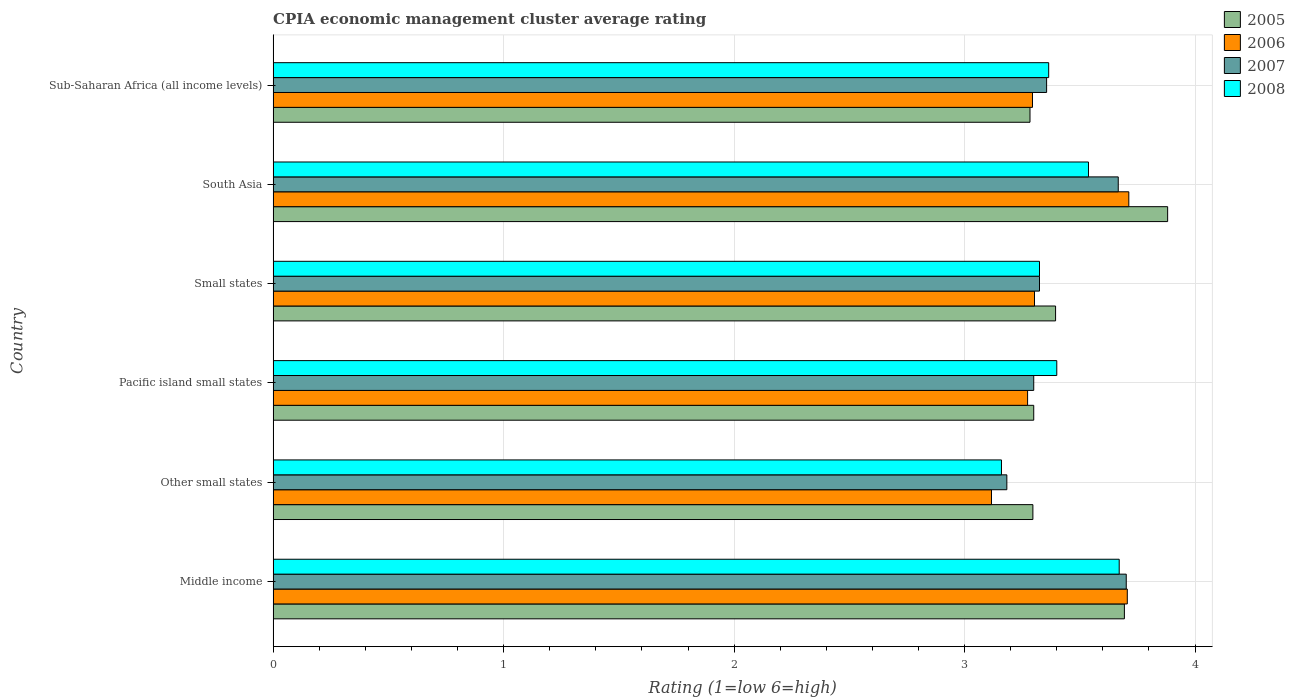How many different coloured bars are there?
Your answer should be compact. 4. Are the number of bars per tick equal to the number of legend labels?
Offer a terse response. Yes. What is the label of the 5th group of bars from the top?
Your answer should be very brief. Other small states. In how many cases, is the number of bars for a given country not equal to the number of legend labels?
Your answer should be compact. 0. What is the CPIA rating in 2005 in Sub-Saharan Africa (all income levels)?
Ensure brevity in your answer.  3.28. Across all countries, what is the maximum CPIA rating in 2005?
Provide a short and direct response. 3.88. Across all countries, what is the minimum CPIA rating in 2008?
Make the answer very short. 3.16. In which country was the CPIA rating in 2007 minimum?
Your response must be concise. Other small states. What is the total CPIA rating in 2008 in the graph?
Give a very brief answer. 20.46. What is the difference between the CPIA rating in 2005 in Small states and that in South Asia?
Offer a very short reply. -0.49. What is the difference between the CPIA rating in 2006 in South Asia and the CPIA rating in 2007 in Middle income?
Offer a terse response. 0.01. What is the average CPIA rating in 2007 per country?
Offer a terse response. 3.42. What is the difference between the CPIA rating in 2008 and CPIA rating in 2006 in Sub-Saharan Africa (all income levels)?
Provide a short and direct response. 0.07. In how many countries, is the CPIA rating in 2008 greater than 2 ?
Your answer should be very brief. 6. What is the ratio of the CPIA rating in 2008 in South Asia to that in Sub-Saharan Africa (all income levels)?
Give a very brief answer. 1.05. Is the CPIA rating in 2006 in Middle income less than that in South Asia?
Give a very brief answer. Yes. What is the difference between the highest and the second highest CPIA rating in 2006?
Provide a short and direct response. 0.01. What is the difference between the highest and the lowest CPIA rating in 2008?
Make the answer very short. 0.51. In how many countries, is the CPIA rating in 2005 greater than the average CPIA rating in 2005 taken over all countries?
Give a very brief answer. 2. Is the sum of the CPIA rating in 2006 in Other small states and Sub-Saharan Africa (all income levels) greater than the maximum CPIA rating in 2007 across all countries?
Your answer should be compact. Yes. Is it the case that in every country, the sum of the CPIA rating in 2007 and CPIA rating in 2005 is greater than the sum of CPIA rating in 2006 and CPIA rating in 2008?
Keep it short and to the point. No. What does the 4th bar from the top in Pacific island small states represents?
Keep it short and to the point. 2005. What does the 3rd bar from the bottom in Sub-Saharan Africa (all income levels) represents?
Keep it short and to the point. 2007. What is the difference between two consecutive major ticks on the X-axis?
Give a very brief answer. 1. Are the values on the major ticks of X-axis written in scientific E-notation?
Provide a succinct answer. No. What is the title of the graph?
Keep it short and to the point. CPIA economic management cluster average rating. Does "2002" appear as one of the legend labels in the graph?
Your answer should be very brief. No. What is the label or title of the X-axis?
Ensure brevity in your answer.  Rating (1=low 6=high). What is the Rating (1=low 6=high) in 2005 in Middle income?
Your response must be concise. 3.69. What is the Rating (1=low 6=high) in 2006 in Middle income?
Offer a very short reply. 3.71. What is the Rating (1=low 6=high) in 2007 in Middle income?
Offer a terse response. 3.7. What is the Rating (1=low 6=high) of 2008 in Middle income?
Provide a succinct answer. 3.67. What is the Rating (1=low 6=high) of 2005 in Other small states?
Keep it short and to the point. 3.3. What is the Rating (1=low 6=high) of 2006 in Other small states?
Your answer should be compact. 3.12. What is the Rating (1=low 6=high) in 2007 in Other small states?
Provide a short and direct response. 3.18. What is the Rating (1=low 6=high) in 2008 in Other small states?
Offer a very short reply. 3.16. What is the Rating (1=low 6=high) of 2005 in Pacific island small states?
Your response must be concise. 3.3. What is the Rating (1=low 6=high) of 2006 in Pacific island small states?
Your answer should be very brief. 3.27. What is the Rating (1=low 6=high) of 2005 in Small states?
Provide a short and direct response. 3.39. What is the Rating (1=low 6=high) of 2006 in Small states?
Your answer should be compact. 3.3. What is the Rating (1=low 6=high) of 2007 in Small states?
Your response must be concise. 3.33. What is the Rating (1=low 6=high) in 2008 in Small states?
Offer a very short reply. 3.33. What is the Rating (1=low 6=high) in 2005 in South Asia?
Offer a very short reply. 3.88. What is the Rating (1=low 6=high) of 2006 in South Asia?
Keep it short and to the point. 3.71. What is the Rating (1=low 6=high) in 2007 in South Asia?
Offer a very short reply. 3.67. What is the Rating (1=low 6=high) of 2008 in South Asia?
Make the answer very short. 3.54. What is the Rating (1=low 6=high) in 2005 in Sub-Saharan Africa (all income levels)?
Provide a succinct answer. 3.28. What is the Rating (1=low 6=high) in 2006 in Sub-Saharan Africa (all income levels)?
Provide a succinct answer. 3.29. What is the Rating (1=low 6=high) of 2007 in Sub-Saharan Africa (all income levels)?
Keep it short and to the point. 3.36. What is the Rating (1=low 6=high) of 2008 in Sub-Saharan Africa (all income levels)?
Offer a terse response. 3.36. Across all countries, what is the maximum Rating (1=low 6=high) in 2005?
Keep it short and to the point. 3.88. Across all countries, what is the maximum Rating (1=low 6=high) of 2006?
Offer a very short reply. 3.71. Across all countries, what is the maximum Rating (1=low 6=high) of 2007?
Ensure brevity in your answer.  3.7. Across all countries, what is the maximum Rating (1=low 6=high) of 2008?
Provide a short and direct response. 3.67. Across all countries, what is the minimum Rating (1=low 6=high) of 2005?
Offer a terse response. 3.28. Across all countries, what is the minimum Rating (1=low 6=high) in 2006?
Give a very brief answer. 3.12. Across all countries, what is the minimum Rating (1=low 6=high) of 2007?
Ensure brevity in your answer.  3.18. Across all countries, what is the minimum Rating (1=low 6=high) of 2008?
Your answer should be very brief. 3.16. What is the total Rating (1=low 6=high) in 2005 in the graph?
Your answer should be very brief. 20.85. What is the total Rating (1=low 6=high) in 2006 in the graph?
Ensure brevity in your answer.  20.41. What is the total Rating (1=low 6=high) in 2007 in the graph?
Ensure brevity in your answer.  20.53. What is the total Rating (1=low 6=high) in 2008 in the graph?
Ensure brevity in your answer.  20.46. What is the difference between the Rating (1=low 6=high) in 2005 in Middle income and that in Other small states?
Keep it short and to the point. 0.4. What is the difference between the Rating (1=low 6=high) of 2006 in Middle income and that in Other small states?
Offer a very short reply. 0.59. What is the difference between the Rating (1=low 6=high) in 2007 in Middle income and that in Other small states?
Ensure brevity in your answer.  0.52. What is the difference between the Rating (1=low 6=high) in 2008 in Middle income and that in Other small states?
Make the answer very short. 0.51. What is the difference between the Rating (1=low 6=high) in 2005 in Middle income and that in Pacific island small states?
Your answer should be very brief. 0.39. What is the difference between the Rating (1=low 6=high) of 2006 in Middle income and that in Pacific island small states?
Keep it short and to the point. 0.43. What is the difference between the Rating (1=low 6=high) in 2007 in Middle income and that in Pacific island small states?
Provide a succinct answer. 0.4. What is the difference between the Rating (1=low 6=high) in 2008 in Middle income and that in Pacific island small states?
Your answer should be very brief. 0.27. What is the difference between the Rating (1=low 6=high) of 2005 in Middle income and that in Small states?
Offer a terse response. 0.3. What is the difference between the Rating (1=low 6=high) of 2006 in Middle income and that in Small states?
Your answer should be compact. 0.4. What is the difference between the Rating (1=low 6=high) of 2007 in Middle income and that in Small states?
Keep it short and to the point. 0.38. What is the difference between the Rating (1=low 6=high) in 2008 in Middle income and that in Small states?
Provide a succinct answer. 0.35. What is the difference between the Rating (1=low 6=high) of 2005 in Middle income and that in South Asia?
Provide a short and direct response. -0.19. What is the difference between the Rating (1=low 6=high) in 2006 in Middle income and that in South Asia?
Offer a very short reply. -0.01. What is the difference between the Rating (1=low 6=high) in 2007 in Middle income and that in South Asia?
Your answer should be very brief. 0.03. What is the difference between the Rating (1=low 6=high) of 2008 in Middle income and that in South Asia?
Provide a short and direct response. 0.13. What is the difference between the Rating (1=low 6=high) of 2005 in Middle income and that in Sub-Saharan Africa (all income levels)?
Your response must be concise. 0.41. What is the difference between the Rating (1=low 6=high) in 2006 in Middle income and that in Sub-Saharan Africa (all income levels)?
Provide a succinct answer. 0.41. What is the difference between the Rating (1=low 6=high) in 2007 in Middle income and that in Sub-Saharan Africa (all income levels)?
Offer a very short reply. 0.35. What is the difference between the Rating (1=low 6=high) in 2008 in Middle income and that in Sub-Saharan Africa (all income levels)?
Offer a terse response. 0.31. What is the difference between the Rating (1=low 6=high) in 2005 in Other small states and that in Pacific island small states?
Your response must be concise. -0. What is the difference between the Rating (1=low 6=high) of 2006 in Other small states and that in Pacific island small states?
Your answer should be compact. -0.16. What is the difference between the Rating (1=low 6=high) of 2007 in Other small states and that in Pacific island small states?
Your answer should be very brief. -0.12. What is the difference between the Rating (1=low 6=high) in 2008 in Other small states and that in Pacific island small states?
Ensure brevity in your answer.  -0.24. What is the difference between the Rating (1=low 6=high) of 2005 in Other small states and that in Small states?
Your answer should be very brief. -0.1. What is the difference between the Rating (1=low 6=high) of 2006 in Other small states and that in Small states?
Your response must be concise. -0.19. What is the difference between the Rating (1=low 6=high) of 2007 in Other small states and that in Small states?
Your answer should be compact. -0.14. What is the difference between the Rating (1=low 6=high) in 2008 in Other small states and that in Small states?
Offer a very short reply. -0.17. What is the difference between the Rating (1=low 6=high) in 2005 in Other small states and that in South Asia?
Keep it short and to the point. -0.58. What is the difference between the Rating (1=low 6=high) of 2006 in Other small states and that in South Asia?
Your response must be concise. -0.6. What is the difference between the Rating (1=low 6=high) in 2007 in Other small states and that in South Asia?
Your answer should be very brief. -0.48. What is the difference between the Rating (1=low 6=high) of 2008 in Other small states and that in South Asia?
Offer a very short reply. -0.38. What is the difference between the Rating (1=low 6=high) in 2005 in Other small states and that in Sub-Saharan Africa (all income levels)?
Your answer should be very brief. 0.01. What is the difference between the Rating (1=low 6=high) of 2006 in Other small states and that in Sub-Saharan Africa (all income levels)?
Keep it short and to the point. -0.18. What is the difference between the Rating (1=low 6=high) of 2007 in Other small states and that in Sub-Saharan Africa (all income levels)?
Provide a short and direct response. -0.17. What is the difference between the Rating (1=low 6=high) in 2008 in Other small states and that in Sub-Saharan Africa (all income levels)?
Offer a very short reply. -0.2. What is the difference between the Rating (1=low 6=high) of 2005 in Pacific island small states and that in Small states?
Keep it short and to the point. -0.09. What is the difference between the Rating (1=low 6=high) of 2006 in Pacific island small states and that in Small states?
Your answer should be compact. -0.03. What is the difference between the Rating (1=low 6=high) of 2007 in Pacific island small states and that in Small states?
Your answer should be very brief. -0.03. What is the difference between the Rating (1=low 6=high) of 2008 in Pacific island small states and that in Small states?
Keep it short and to the point. 0.07. What is the difference between the Rating (1=low 6=high) of 2005 in Pacific island small states and that in South Asia?
Keep it short and to the point. -0.58. What is the difference between the Rating (1=low 6=high) of 2006 in Pacific island small states and that in South Asia?
Offer a terse response. -0.44. What is the difference between the Rating (1=low 6=high) in 2007 in Pacific island small states and that in South Asia?
Offer a terse response. -0.37. What is the difference between the Rating (1=low 6=high) in 2008 in Pacific island small states and that in South Asia?
Give a very brief answer. -0.14. What is the difference between the Rating (1=low 6=high) of 2005 in Pacific island small states and that in Sub-Saharan Africa (all income levels)?
Give a very brief answer. 0.02. What is the difference between the Rating (1=low 6=high) in 2006 in Pacific island small states and that in Sub-Saharan Africa (all income levels)?
Provide a succinct answer. -0.02. What is the difference between the Rating (1=low 6=high) of 2007 in Pacific island small states and that in Sub-Saharan Africa (all income levels)?
Your answer should be very brief. -0.06. What is the difference between the Rating (1=low 6=high) of 2008 in Pacific island small states and that in Sub-Saharan Africa (all income levels)?
Your answer should be compact. 0.04. What is the difference between the Rating (1=low 6=high) of 2005 in Small states and that in South Asia?
Your answer should be very brief. -0.49. What is the difference between the Rating (1=low 6=high) in 2006 in Small states and that in South Asia?
Provide a succinct answer. -0.41. What is the difference between the Rating (1=low 6=high) in 2007 in Small states and that in South Asia?
Offer a terse response. -0.34. What is the difference between the Rating (1=low 6=high) of 2008 in Small states and that in South Asia?
Keep it short and to the point. -0.21. What is the difference between the Rating (1=low 6=high) in 2005 in Small states and that in Sub-Saharan Africa (all income levels)?
Ensure brevity in your answer.  0.11. What is the difference between the Rating (1=low 6=high) of 2006 in Small states and that in Sub-Saharan Africa (all income levels)?
Offer a terse response. 0.01. What is the difference between the Rating (1=low 6=high) in 2007 in Small states and that in Sub-Saharan Africa (all income levels)?
Make the answer very short. -0.03. What is the difference between the Rating (1=low 6=high) in 2008 in Small states and that in Sub-Saharan Africa (all income levels)?
Give a very brief answer. -0.04. What is the difference between the Rating (1=low 6=high) in 2005 in South Asia and that in Sub-Saharan Africa (all income levels)?
Keep it short and to the point. 0.6. What is the difference between the Rating (1=low 6=high) of 2006 in South Asia and that in Sub-Saharan Africa (all income levels)?
Offer a terse response. 0.42. What is the difference between the Rating (1=low 6=high) in 2007 in South Asia and that in Sub-Saharan Africa (all income levels)?
Your answer should be very brief. 0.31. What is the difference between the Rating (1=low 6=high) in 2008 in South Asia and that in Sub-Saharan Africa (all income levels)?
Give a very brief answer. 0.17. What is the difference between the Rating (1=low 6=high) of 2005 in Middle income and the Rating (1=low 6=high) of 2006 in Other small states?
Offer a very short reply. 0.58. What is the difference between the Rating (1=low 6=high) in 2005 in Middle income and the Rating (1=low 6=high) in 2007 in Other small states?
Your answer should be very brief. 0.51. What is the difference between the Rating (1=low 6=high) in 2005 in Middle income and the Rating (1=low 6=high) in 2008 in Other small states?
Provide a short and direct response. 0.53. What is the difference between the Rating (1=low 6=high) in 2006 in Middle income and the Rating (1=low 6=high) in 2007 in Other small states?
Give a very brief answer. 0.52. What is the difference between the Rating (1=low 6=high) of 2006 in Middle income and the Rating (1=low 6=high) of 2008 in Other small states?
Offer a terse response. 0.55. What is the difference between the Rating (1=low 6=high) in 2007 in Middle income and the Rating (1=low 6=high) in 2008 in Other small states?
Offer a very short reply. 0.54. What is the difference between the Rating (1=low 6=high) of 2005 in Middle income and the Rating (1=low 6=high) of 2006 in Pacific island small states?
Your response must be concise. 0.42. What is the difference between the Rating (1=low 6=high) in 2005 in Middle income and the Rating (1=low 6=high) in 2007 in Pacific island small states?
Your response must be concise. 0.39. What is the difference between the Rating (1=low 6=high) in 2005 in Middle income and the Rating (1=low 6=high) in 2008 in Pacific island small states?
Your answer should be compact. 0.29. What is the difference between the Rating (1=low 6=high) in 2006 in Middle income and the Rating (1=low 6=high) in 2007 in Pacific island small states?
Ensure brevity in your answer.  0.41. What is the difference between the Rating (1=low 6=high) of 2006 in Middle income and the Rating (1=low 6=high) of 2008 in Pacific island small states?
Provide a short and direct response. 0.31. What is the difference between the Rating (1=low 6=high) in 2007 in Middle income and the Rating (1=low 6=high) in 2008 in Pacific island small states?
Ensure brevity in your answer.  0.3. What is the difference between the Rating (1=low 6=high) in 2005 in Middle income and the Rating (1=low 6=high) in 2006 in Small states?
Offer a very short reply. 0.39. What is the difference between the Rating (1=low 6=high) in 2005 in Middle income and the Rating (1=low 6=high) in 2007 in Small states?
Your answer should be compact. 0.37. What is the difference between the Rating (1=low 6=high) of 2005 in Middle income and the Rating (1=low 6=high) of 2008 in Small states?
Give a very brief answer. 0.37. What is the difference between the Rating (1=low 6=high) of 2006 in Middle income and the Rating (1=low 6=high) of 2007 in Small states?
Give a very brief answer. 0.38. What is the difference between the Rating (1=low 6=high) of 2006 in Middle income and the Rating (1=low 6=high) of 2008 in Small states?
Provide a succinct answer. 0.38. What is the difference between the Rating (1=low 6=high) of 2007 in Middle income and the Rating (1=low 6=high) of 2008 in Small states?
Make the answer very short. 0.38. What is the difference between the Rating (1=low 6=high) of 2005 in Middle income and the Rating (1=low 6=high) of 2006 in South Asia?
Provide a short and direct response. -0.02. What is the difference between the Rating (1=low 6=high) in 2005 in Middle income and the Rating (1=low 6=high) in 2007 in South Asia?
Your answer should be compact. 0.03. What is the difference between the Rating (1=low 6=high) of 2005 in Middle income and the Rating (1=low 6=high) of 2008 in South Asia?
Provide a succinct answer. 0.16. What is the difference between the Rating (1=low 6=high) of 2006 in Middle income and the Rating (1=low 6=high) of 2007 in South Asia?
Offer a very short reply. 0.04. What is the difference between the Rating (1=low 6=high) of 2006 in Middle income and the Rating (1=low 6=high) of 2008 in South Asia?
Give a very brief answer. 0.17. What is the difference between the Rating (1=low 6=high) in 2007 in Middle income and the Rating (1=low 6=high) in 2008 in South Asia?
Make the answer very short. 0.16. What is the difference between the Rating (1=low 6=high) in 2005 in Middle income and the Rating (1=low 6=high) in 2006 in Sub-Saharan Africa (all income levels)?
Offer a very short reply. 0.4. What is the difference between the Rating (1=low 6=high) of 2005 in Middle income and the Rating (1=low 6=high) of 2007 in Sub-Saharan Africa (all income levels)?
Your answer should be compact. 0.34. What is the difference between the Rating (1=low 6=high) of 2005 in Middle income and the Rating (1=low 6=high) of 2008 in Sub-Saharan Africa (all income levels)?
Ensure brevity in your answer.  0.33. What is the difference between the Rating (1=low 6=high) in 2006 in Middle income and the Rating (1=low 6=high) in 2007 in Sub-Saharan Africa (all income levels)?
Offer a very short reply. 0.35. What is the difference between the Rating (1=low 6=high) in 2006 in Middle income and the Rating (1=low 6=high) in 2008 in Sub-Saharan Africa (all income levels)?
Provide a short and direct response. 0.34. What is the difference between the Rating (1=low 6=high) of 2007 in Middle income and the Rating (1=low 6=high) of 2008 in Sub-Saharan Africa (all income levels)?
Your answer should be very brief. 0.34. What is the difference between the Rating (1=low 6=high) in 2005 in Other small states and the Rating (1=low 6=high) in 2006 in Pacific island small states?
Provide a succinct answer. 0.02. What is the difference between the Rating (1=low 6=high) in 2005 in Other small states and the Rating (1=low 6=high) in 2007 in Pacific island small states?
Provide a short and direct response. -0. What is the difference between the Rating (1=low 6=high) in 2005 in Other small states and the Rating (1=low 6=high) in 2008 in Pacific island small states?
Provide a succinct answer. -0.1. What is the difference between the Rating (1=low 6=high) in 2006 in Other small states and the Rating (1=low 6=high) in 2007 in Pacific island small states?
Give a very brief answer. -0.18. What is the difference between the Rating (1=low 6=high) in 2006 in Other small states and the Rating (1=low 6=high) in 2008 in Pacific island small states?
Your answer should be compact. -0.28. What is the difference between the Rating (1=low 6=high) of 2007 in Other small states and the Rating (1=low 6=high) of 2008 in Pacific island small states?
Provide a succinct answer. -0.22. What is the difference between the Rating (1=low 6=high) of 2005 in Other small states and the Rating (1=low 6=high) of 2006 in Small states?
Your response must be concise. -0.01. What is the difference between the Rating (1=low 6=high) of 2005 in Other small states and the Rating (1=low 6=high) of 2007 in Small states?
Provide a short and direct response. -0.03. What is the difference between the Rating (1=low 6=high) of 2005 in Other small states and the Rating (1=low 6=high) of 2008 in Small states?
Keep it short and to the point. -0.03. What is the difference between the Rating (1=low 6=high) in 2006 in Other small states and the Rating (1=low 6=high) in 2007 in Small states?
Offer a terse response. -0.21. What is the difference between the Rating (1=low 6=high) in 2006 in Other small states and the Rating (1=low 6=high) in 2008 in Small states?
Your response must be concise. -0.21. What is the difference between the Rating (1=low 6=high) of 2007 in Other small states and the Rating (1=low 6=high) of 2008 in Small states?
Offer a very short reply. -0.14. What is the difference between the Rating (1=low 6=high) in 2005 in Other small states and the Rating (1=low 6=high) in 2006 in South Asia?
Your answer should be very brief. -0.42. What is the difference between the Rating (1=low 6=high) in 2005 in Other small states and the Rating (1=low 6=high) in 2007 in South Asia?
Keep it short and to the point. -0.37. What is the difference between the Rating (1=low 6=high) in 2005 in Other small states and the Rating (1=low 6=high) in 2008 in South Asia?
Keep it short and to the point. -0.24. What is the difference between the Rating (1=low 6=high) of 2006 in Other small states and the Rating (1=low 6=high) of 2007 in South Asia?
Your response must be concise. -0.55. What is the difference between the Rating (1=low 6=high) in 2006 in Other small states and the Rating (1=low 6=high) in 2008 in South Asia?
Offer a very short reply. -0.42. What is the difference between the Rating (1=low 6=high) of 2007 in Other small states and the Rating (1=low 6=high) of 2008 in South Asia?
Make the answer very short. -0.35. What is the difference between the Rating (1=low 6=high) of 2005 in Other small states and the Rating (1=low 6=high) of 2006 in Sub-Saharan Africa (all income levels)?
Offer a terse response. 0. What is the difference between the Rating (1=low 6=high) in 2005 in Other small states and the Rating (1=low 6=high) in 2007 in Sub-Saharan Africa (all income levels)?
Give a very brief answer. -0.06. What is the difference between the Rating (1=low 6=high) of 2005 in Other small states and the Rating (1=low 6=high) of 2008 in Sub-Saharan Africa (all income levels)?
Offer a very short reply. -0.07. What is the difference between the Rating (1=low 6=high) of 2006 in Other small states and the Rating (1=low 6=high) of 2007 in Sub-Saharan Africa (all income levels)?
Your answer should be compact. -0.24. What is the difference between the Rating (1=low 6=high) of 2006 in Other small states and the Rating (1=low 6=high) of 2008 in Sub-Saharan Africa (all income levels)?
Make the answer very short. -0.25. What is the difference between the Rating (1=low 6=high) of 2007 in Other small states and the Rating (1=low 6=high) of 2008 in Sub-Saharan Africa (all income levels)?
Keep it short and to the point. -0.18. What is the difference between the Rating (1=low 6=high) in 2005 in Pacific island small states and the Rating (1=low 6=high) in 2006 in Small states?
Your response must be concise. -0. What is the difference between the Rating (1=low 6=high) of 2005 in Pacific island small states and the Rating (1=low 6=high) of 2007 in Small states?
Keep it short and to the point. -0.03. What is the difference between the Rating (1=low 6=high) of 2005 in Pacific island small states and the Rating (1=low 6=high) of 2008 in Small states?
Keep it short and to the point. -0.03. What is the difference between the Rating (1=low 6=high) of 2006 in Pacific island small states and the Rating (1=low 6=high) of 2007 in Small states?
Your response must be concise. -0.05. What is the difference between the Rating (1=low 6=high) of 2006 in Pacific island small states and the Rating (1=low 6=high) of 2008 in Small states?
Your response must be concise. -0.05. What is the difference between the Rating (1=low 6=high) in 2007 in Pacific island small states and the Rating (1=low 6=high) in 2008 in Small states?
Give a very brief answer. -0.03. What is the difference between the Rating (1=low 6=high) of 2005 in Pacific island small states and the Rating (1=low 6=high) of 2006 in South Asia?
Offer a very short reply. -0.41. What is the difference between the Rating (1=low 6=high) in 2005 in Pacific island small states and the Rating (1=low 6=high) in 2007 in South Asia?
Your answer should be very brief. -0.37. What is the difference between the Rating (1=low 6=high) of 2005 in Pacific island small states and the Rating (1=low 6=high) of 2008 in South Asia?
Offer a terse response. -0.24. What is the difference between the Rating (1=low 6=high) of 2006 in Pacific island small states and the Rating (1=low 6=high) of 2007 in South Asia?
Make the answer very short. -0.39. What is the difference between the Rating (1=low 6=high) in 2006 in Pacific island small states and the Rating (1=low 6=high) in 2008 in South Asia?
Keep it short and to the point. -0.26. What is the difference between the Rating (1=low 6=high) in 2007 in Pacific island small states and the Rating (1=low 6=high) in 2008 in South Asia?
Give a very brief answer. -0.24. What is the difference between the Rating (1=low 6=high) of 2005 in Pacific island small states and the Rating (1=low 6=high) of 2006 in Sub-Saharan Africa (all income levels)?
Offer a very short reply. 0.01. What is the difference between the Rating (1=low 6=high) in 2005 in Pacific island small states and the Rating (1=low 6=high) in 2007 in Sub-Saharan Africa (all income levels)?
Provide a short and direct response. -0.06. What is the difference between the Rating (1=low 6=high) in 2005 in Pacific island small states and the Rating (1=low 6=high) in 2008 in Sub-Saharan Africa (all income levels)?
Your answer should be compact. -0.06. What is the difference between the Rating (1=low 6=high) in 2006 in Pacific island small states and the Rating (1=low 6=high) in 2007 in Sub-Saharan Africa (all income levels)?
Your response must be concise. -0.08. What is the difference between the Rating (1=low 6=high) in 2006 in Pacific island small states and the Rating (1=low 6=high) in 2008 in Sub-Saharan Africa (all income levels)?
Provide a succinct answer. -0.09. What is the difference between the Rating (1=low 6=high) in 2007 in Pacific island small states and the Rating (1=low 6=high) in 2008 in Sub-Saharan Africa (all income levels)?
Your answer should be very brief. -0.06. What is the difference between the Rating (1=low 6=high) in 2005 in Small states and the Rating (1=low 6=high) in 2006 in South Asia?
Offer a terse response. -0.32. What is the difference between the Rating (1=low 6=high) of 2005 in Small states and the Rating (1=low 6=high) of 2007 in South Asia?
Keep it short and to the point. -0.27. What is the difference between the Rating (1=low 6=high) of 2005 in Small states and the Rating (1=low 6=high) of 2008 in South Asia?
Your answer should be very brief. -0.14. What is the difference between the Rating (1=low 6=high) in 2006 in Small states and the Rating (1=low 6=high) in 2007 in South Asia?
Provide a succinct answer. -0.36. What is the difference between the Rating (1=low 6=high) in 2006 in Small states and the Rating (1=low 6=high) in 2008 in South Asia?
Your answer should be compact. -0.23. What is the difference between the Rating (1=low 6=high) of 2007 in Small states and the Rating (1=low 6=high) of 2008 in South Asia?
Provide a short and direct response. -0.21. What is the difference between the Rating (1=low 6=high) of 2005 in Small states and the Rating (1=low 6=high) of 2006 in Sub-Saharan Africa (all income levels)?
Your answer should be compact. 0.1. What is the difference between the Rating (1=low 6=high) in 2005 in Small states and the Rating (1=low 6=high) in 2007 in Sub-Saharan Africa (all income levels)?
Offer a terse response. 0.04. What is the difference between the Rating (1=low 6=high) of 2005 in Small states and the Rating (1=low 6=high) of 2008 in Sub-Saharan Africa (all income levels)?
Provide a short and direct response. 0.03. What is the difference between the Rating (1=low 6=high) in 2006 in Small states and the Rating (1=low 6=high) in 2007 in Sub-Saharan Africa (all income levels)?
Ensure brevity in your answer.  -0.05. What is the difference between the Rating (1=low 6=high) in 2006 in Small states and the Rating (1=low 6=high) in 2008 in Sub-Saharan Africa (all income levels)?
Your answer should be compact. -0.06. What is the difference between the Rating (1=low 6=high) in 2007 in Small states and the Rating (1=low 6=high) in 2008 in Sub-Saharan Africa (all income levels)?
Your answer should be very brief. -0.04. What is the difference between the Rating (1=low 6=high) of 2005 in South Asia and the Rating (1=low 6=high) of 2006 in Sub-Saharan Africa (all income levels)?
Your answer should be very brief. 0.59. What is the difference between the Rating (1=low 6=high) in 2005 in South Asia and the Rating (1=low 6=high) in 2007 in Sub-Saharan Africa (all income levels)?
Keep it short and to the point. 0.53. What is the difference between the Rating (1=low 6=high) of 2005 in South Asia and the Rating (1=low 6=high) of 2008 in Sub-Saharan Africa (all income levels)?
Offer a terse response. 0.52. What is the difference between the Rating (1=low 6=high) in 2006 in South Asia and the Rating (1=low 6=high) in 2007 in Sub-Saharan Africa (all income levels)?
Keep it short and to the point. 0.36. What is the difference between the Rating (1=low 6=high) in 2006 in South Asia and the Rating (1=low 6=high) in 2008 in Sub-Saharan Africa (all income levels)?
Keep it short and to the point. 0.35. What is the difference between the Rating (1=low 6=high) of 2007 in South Asia and the Rating (1=low 6=high) of 2008 in Sub-Saharan Africa (all income levels)?
Ensure brevity in your answer.  0.3. What is the average Rating (1=low 6=high) in 2005 per country?
Offer a very short reply. 3.47. What is the average Rating (1=low 6=high) of 2006 per country?
Make the answer very short. 3.4. What is the average Rating (1=low 6=high) in 2007 per country?
Give a very brief answer. 3.42. What is the average Rating (1=low 6=high) in 2008 per country?
Your answer should be very brief. 3.41. What is the difference between the Rating (1=low 6=high) in 2005 and Rating (1=low 6=high) in 2006 in Middle income?
Make the answer very short. -0.01. What is the difference between the Rating (1=low 6=high) of 2005 and Rating (1=low 6=high) of 2007 in Middle income?
Offer a terse response. -0.01. What is the difference between the Rating (1=low 6=high) in 2005 and Rating (1=low 6=high) in 2008 in Middle income?
Your response must be concise. 0.02. What is the difference between the Rating (1=low 6=high) of 2006 and Rating (1=low 6=high) of 2007 in Middle income?
Provide a short and direct response. 0. What is the difference between the Rating (1=low 6=high) in 2006 and Rating (1=low 6=high) in 2008 in Middle income?
Make the answer very short. 0.04. What is the difference between the Rating (1=low 6=high) of 2007 and Rating (1=low 6=high) of 2008 in Middle income?
Your answer should be very brief. 0.03. What is the difference between the Rating (1=low 6=high) in 2005 and Rating (1=low 6=high) in 2006 in Other small states?
Your answer should be very brief. 0.18. What is the difference between the Rating (1=low 6=high) in 2005 and Rating (1=low 6=high) in 2007 in Other small states?
Provide a succinct answer. 0.11. What is the difference between the Rating (1=low 6=high) in 2005 and Rating (1=low 6=high) in 2008 in Other small states?
Offer a very short reply. 0.14. What is the difference between the Rating (1=low 6=high) in 2006 and Rating (1=low 6=high) in 2007 in Other small states?
Make the answer very short. -0.07. What is the difference between the Rating (1=low 6=high) in 2006 and Rating (1=low 6=high) in 2008 in Other small states?
Ensure brevity in your answer.  -0.04. What is the difference between the Rating (1=low 6=high) in 2007 and Rating (1=low 6=high) in 2008 in Other small states?
Your response must be concise. 0.02. What is the difference between the Rating (1=low 6=high) in 2005 and Rating (1=low 6=high) in 2006 in Pacific island small states?
Offer a terse response. 0.03. What is the difference between the Rating (1=low 6=high) of 2005 and Rating (1=low 6=high) of 2007 in Pacific island small states?
Keep it short and to the point. 0. What is the difference between the Rating (1=low 6=high) of 2005 and Rating (1=low 6=high) of 2008 in Pacific island small states?
Your answer should be compact. -0.1. What is the difference between the Rating (1=low 6=high) of 2006 and Rating (1=low 6=high) of 2007 in Pacific island small states?
Your response must be concise. -0.03. What is the difference between the Rating (1=low 6=high) of 2006 and Rating (1=low 6=high) of 2008 in Pacific island small states?
Ensure brevity in your answer.  -0.13. What is the difference between the Rating (1=low 6=high) of 2007 and Rating (1=low 6=high) of 2008 in Pacific island small states?
Your answer should be compact. -0.1. What is the difference between the Rating (1=low 6=high) in 2005 and Rating (1=low 6=high) in 2006 in Small states?
Keep it short and to the point. 0.09. What is the difference between the Rating (1=low 6=high) in 2005 and Rating (1=low 6=high) in 2007 in Small states?
Your answer should be compact. 0.07. What is the difference between the Rating (1=low 6=high) of 2005 and Rating (1=low 6=high) of 2008 in Small states?
Ensure brevity in your answer.  0.07. What is the difference between the Rating (1=low 6=high) in 2006 and Rating (1=low 6=high) in 2007 in Small states?
Offer a very short reply. -0.02. What is the difference between the Rating (1=low 6=high) of 2006 and Rating (1=low 6=high) of 2008 in Small states?
Provide a succinct answer. -0.02. What is the difference between the Rating (1=low 6=high) of 2005 and Rating (1=low 6=high) of 2006 in South Asia?
Make the answer very short. 0.17. What is the difference between the Rating (1=low 6=high) of 2005 and Rating (1=low 6=high) of 2007 in South Asia?
Give a very brief answer. 0.21. What is the difference between the Rating (1=low 6=high) of 2005 and Rating (1=low 6=high) of 2008 in South Asia?
Provide a short and direct response. 0.34. What is the difference between the Rating (1=low 6=high) in 2006 and Rating (1=low 6=high) in 2007 in South Asia?
Provide a short and direct response. 0.05. What is the difference between the Rating (1=low 6=high) of 2006 and Rating (1=low 6=high) of 2008 in South Asia?
Your answer should be very brief. 0.17. What is the difference between the Rating (1=low 6=high) in 2007 and Rating (1=low 6=high) in 2008 in South Asia?
Offer a terse response. 0.13. What is the difference between the Rating (1=low 6=high) of 2005 and Rating (1=low 6=high) of 2006 in Sub-Saharan Africa (all income levels)?
Your answer should be very brief. -0.01. What is the difference between the Rating (1=low 6=high) in 2005 and Rating (1=low 6=high) in 2007 in Sub-Saharan Africa (all income levels)?
Offer a very short reply. -0.07. What is the difference between the Rating (1=low 6=high) of 2005 and Rating (1=low 6=high) of 2008 in Sub-Saharan Africa (all income levels)?
Your response must be concise. -0.08. What is the difference between the Rating (1=low 6=high) of 2006 and Rating (1=low 6=high) of 2007 in Sub-Saharan Africa (all income levels)?
Keep it short and to the point. -0.06. What is the difference between the Rating (1=low 6=high) in 2006 and Rating (1=low 6=high) in 2008 in Sub-Saharan Africa (all income levels)?
Offer a very short reply. -0.07. What is the difference between the Rating (1=low 6=high) of 2007 and Rating (1=low 6=high) of 2008 in Sub-Saharan Africa (all income levels)?
Make the answer very short. -0.01. What is the ratio of the Rating (1=low 6=high) in 2005 in Middle income to that in Other small states?
Offer a very short reply. 1.12. What is the ratio of the Rating (1=low 6=high) in 2006 in Middle income to that in Other small states?
Provide a succinct answer. 1.19. What is the ratio of the Rating (1=low 6=high) in 2007 in Middle income to that in Other small states?
Your answer should be compact. 1.16. What is the ratio of the Rating (1=low 6=high) of 2008 in Middle income to that in Other small states?
Offer a terse response. 1.16. What is the ratio of the Rating (1=low 6=high) in 2005 in Middle income to that in Pacific island small states?
Offer a very short reply. 1.12. What is the ratio of the Rating (1=low 6=high) in 2006 in Middle income to that in Pacific island small states?
Your answer should be very brief. 1.13. What is the ratio of the Rating (1=low 6=high) in 2007 in Middle income to that in Pacific island small states?
Keep it short and to the point. 1.12. What is the ratio of the Rating (1=low 6=high) of 2008 in Middle income to that in Pacific island small states?
Your response must be concise. 1.08. What is the ratio of the Rating (1=low 6=high) in 2005 in Middle income to that in Small states?
Your response must be concise. 1.09. What is the ratio of the Rating (1=low 6=high) of 2006 in Middle income to that in Small states?
Your answer should be very brief. 1.12. What is the ratio of the Rating (1=low 6=high) in 2007 in Middle income to that in Small states?
Your response must be concise. 1.11. What is the ratio of the Rating (1=low 6=high) in 2008 in Middle income to that in Small states?
Offer a terse response. 1.1. What is the ratio of the Rating (1=low 6=high) of 2005 in Middle income to that in South Asia?
Your response must be concise. 0.95. What is the ratio of the Rating (1=low 6=high) of 2007 in Middle income to that in South Asia?
Provide a short and direct response. 1.01. What is the ratio of the Rating (1=low 6=high) of 2008 in Middle income to that in South Asia?
Keep it short and to the point. 1.04. What is the ratio of the Rating (1=low 6=high) in 2005 in Middle income to that in Sub-Saharan Africa (all income levels)?
Give a very brief answer. 1.12. What is the ratio of the Rating (1=low 6=high) of 2006 in Middle income to that in Sub-Saharan Africa (all income levels)?
Keep it short and to the point. 1.12. What is the ratio of the Rating (1=low 6=high) in 2007 in Middle income to that in Sub-Saharan Africa (all income levels)?
Make the answer very short. 1.1. What is the ratio of the Rating (1=low 6=high) in 2005 in Other small states to that in Pacific island small states?
Offer a very short reply. 1. What is the ratio of the Rating (1=low 6=high) in 2006 in Other small states to that in Pacific island small states?
Your answer should be compact. 0.95. What is the ratio of the Rating (1=low 6=high) of 2007 in Other small states to that in Pacific island small states?
Make the answer very short. 0.96. What is the ratio of the Rating (1=low 6=high) of 2008 in Other small states to that in Pacific island small states?
Give a very brief answer. 0.93. What is the ratio of the Rating (1=low 6=high) in 2005 in Other small states to that in Small states?
Keep it short and to the point. 0.97. What is the ratio of the Rating (1=low 6=high) in 2006 in Other small states to that in Small states?
Provide a succinct answer. 0.94. What is the ratio of the Rating (1=low 6=high) in 2007 in Other small states to that in Small states?
Offer a terse response. 0.96. What is the ratio of the Rating (1=low 6=high) in 2008 in Other small states to that in Small states?
Make the answer very short. 0.95. What is the ratio of the Rating (1=low 6=high) of 2005 in Other small states to that in South Asia?
Provide a short and direct response. 0.85. What is the ratio of the Rating (1=low 6=high) in 2006 in Other small states to that in South Asia?
Your answer should be very brief. 0.84. What is the ratio of the Rating (1=low 6=high) in 2007 in Other small states to that in South Asia?
Make the answer very short. 0.87. What is the ratio of the Rating (1=low 6=high) of 2008 in Other small states to that in South Asia?
Keep it short and to the point. 0.89. What is the ratio of the Rating (1=low 6=high) in 2006 in Other small states to that in Sub-Saharan Africa (all income levels)?
Provide a succinct answer. 0.95. What is the ratio of the Rating (1=low 6=high) in 2007 in Other small states to that in Sub-Saharan Africa (all income levels)?
Keep it short and to the point. 0.95. What is the ratio of the Rating (1=low 6=high) of 2008 in Other small states to that in Sub-Saharan Africa (all income levels)?
Give a very brief answer. 0.94. What is the ratio of the Rating (1=low 6=high) in 2005 in Pacific island small states to that in Small states?
Provide a succinct answer. 0.97. What is the ratio of the Rating (1=low 6=high) in 2006 in Pacific island small states to that in Small states?
Offer a terse response. 0.99. What is the ratio of the Rating (1=low 6=high) in 2008 in Pacific island small states to that in Small states?
Offer a terse response. 1.02. What is the ratio of the Rating (1=low 6=high) in 2005 in Pacific island small states to that in South Asia?
Your response must be concise. 0.85. What is the ratio of the Rating (1=low 6=high) in 2006 in Pacific island small states to that in South Asia?
Offer a very short reply. 0.88. What is the ratio of the Rating (1=low 6=high) in 2008 in Pacific island small states to that in South Asia?
Your response must be concise. 0.96. What is the ratio of the Rating (1=low 6=high) in 2006 in Pacific island small states to that in Sub-Saharan Africa (all income levels)?
Your response must be concise. 0.99. What is the ratio of the Rating (1=low 6=high) in 2007 in Pacific island small states to that in Sub-Saharan Africa (all income levels)?
Offer a terse response. 0.98. What is the ratio of the Rating (1=low 6=high) of 2008 in Pacific island small states to that in Sub-Saharan Africa (all income levels)?
Offer a very short reply. 1.01. What is the ratio of the Rating (1=low 6=high) in 2005 in Small states to that in South Asia?
Provide a succinct answer. 0.87. What is the ratio of the Rating (1=low 6=high) in 2006 in Small states to that in South Asia?
Make the answer very short. 0.89. What is the ratio of the Rating (1=low 6=high) in 2007 in Small states to that in South Asia?
Provide a short and direct response. 0.91. What is the ratio of the Rating (1=low 6=high) in 2008 in Small states to that in South Asia?
Ensure brevity in your answer.  0.94. What is the ratio of the Rating (1=low 6=high) of 2005 in Small states to that in Sub-Saharan Africa (all income levels)?
Keep it short and to the point. 1.03. What is the ratio of the Rating (1=low 6=high) of 2007 in Small states to that in Sub-Saharan Africa (all income levels)?
Ensure brevity in your answer.  0.99. What is the ratio of the Rating (1=low 6=high) in 2008 in Small states to that in Sub-Saharan Africa (all income levels)?
Keep it short and to the point. 0.99. What is the ratio of the Rating (1=low 6=high) of 2005 in South Asia to that in Sub-Saharan Africa (all income levels)?
Your response must be concise. 1.18. What is the ratio of the Rating (1=low 6=high) of 2006 in South Asia to that in Sub-Saharan Africa (all income levels)?
Offer a very short reply. 1.13. What is the ratio of the Rating (1=low 6=high) of 2007 in South Asia to that in Sub-Saharan Africa (all income levels)?
Provide a succinct answer. 1.09. What is the ratio of the Rating (1=low 6=high) in 2008 in South Asia to that in Sub-Saharan Africa (all income levels)?
Give a very brief answer. 1.05. What is the difference between the highest and the second highest Rating (1=low 6=high) of 2005?
Give a very brief answer. 0.19. What is the difference between the highest and the second highest Rating (1=low 6=high) of 2006?
Your answer should be compact. 0.01. What is the difference between the highest and the second highest Rating (1=low 6=high) of 2007?
Make the answer very short. 0.03. What is the difference between the highest and the second highest Rating (1=low 6=high) of 2008?
Offer a terse response. 0.13. What is the difference between the highest and the lowest Rating (1=low 6=high) of 2005?
Give a very brief answer. 0.6. What is the difference between the highest and the lowest Rating (1=low 6=high) of 2006?
Provide a short and direct response. 0.6. What is the difference between the highest and the lowest Rating (1=low 6=high) of 2007?
Offer a terse response. 0.52. What is the difference between the highest and the lowest Rating (1=low 6=high) of 2008?
Make the answer very short. 0.51. 